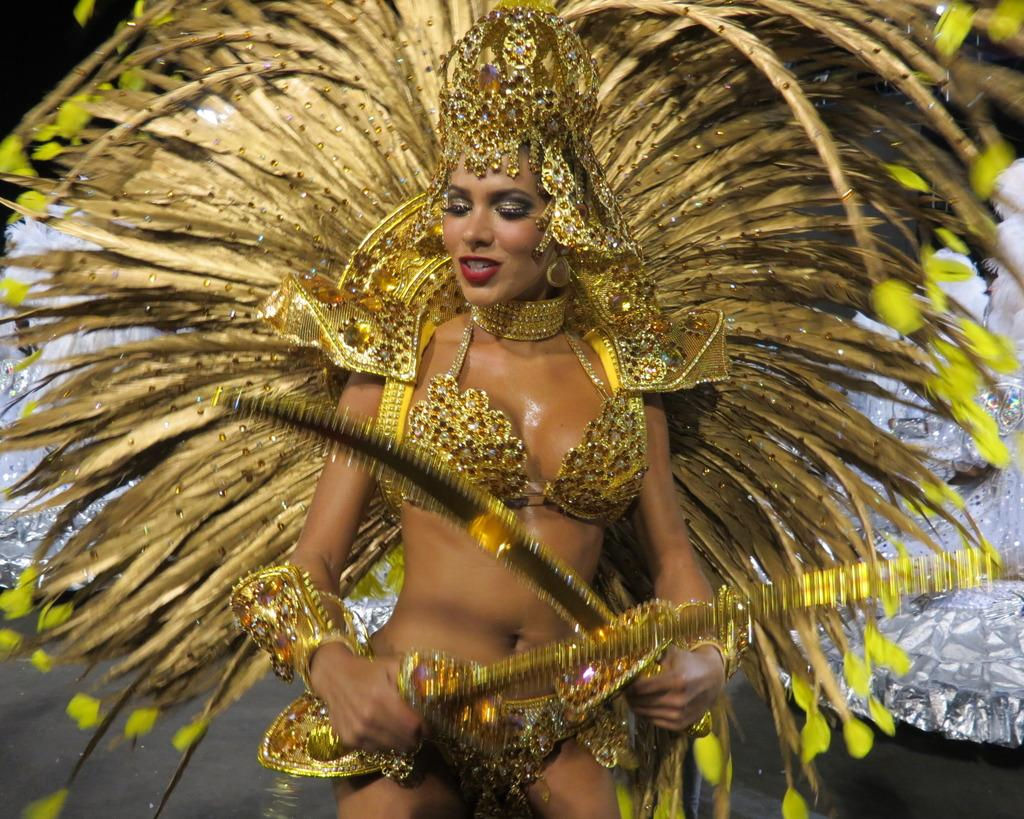Who is present in the image? There is a woman in the image. What is the woman wearing? The woman is wearing a costume. What can be seen in the background of the image? There is a curtain in the background of the image. What type of honey is the woman using to draw on the chalkboard in the image? There is no chalkboard, honey, or chalk present in the image. 